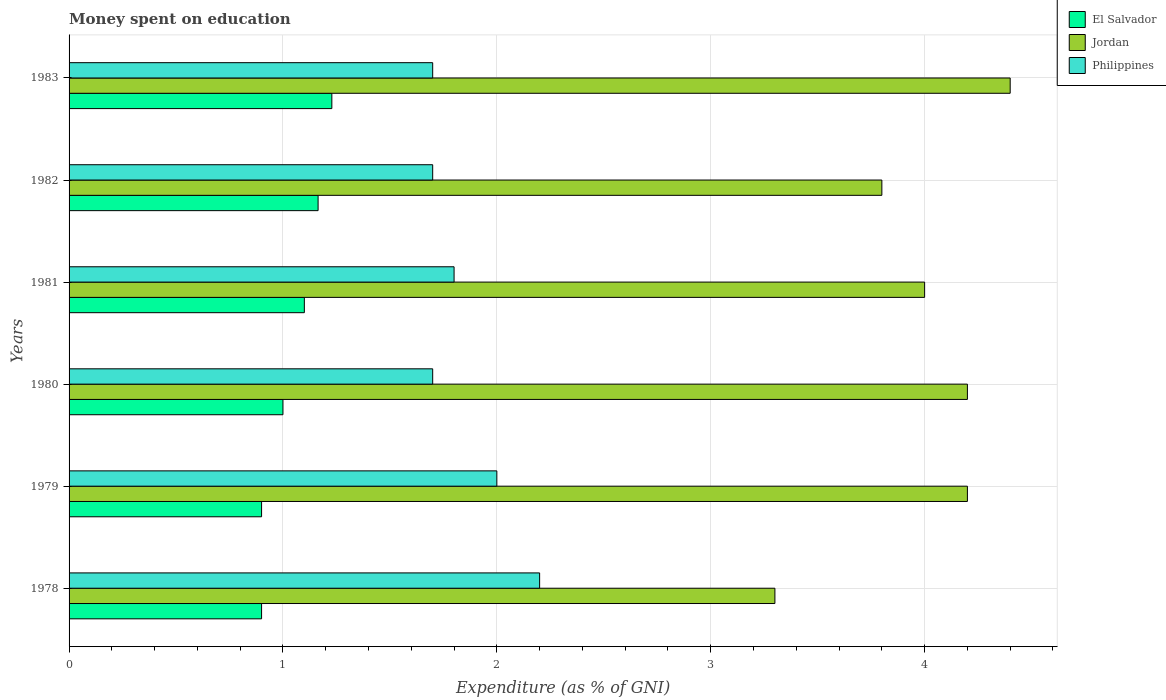How many different coloured bars are there?
Your response must be concise. 3. Are the number of bars per tick equal to the number of legend labels?
Provide a short and direct response. Yes. How many bars are there on the 2nd tick from the bottom?
Provide a short and direct response. 3. What is the label of the 3rd group of bars from the top?
Provide a succinct answer. 1981. In how many cases, is the number of bars for a given year not equal to the number of legend labels?
Provide a short and direct response. 0. What is the amount of money spent on education in Philippines in 1983?
Keep it short and to the point. 1.7. Across all years, what is the minimum amount of money spent on education in El Salvador?
Provide a succinct answer. 0.9. In which year was the amount of money spent on education in El Salvador maximum?
Provide a short and direct response. 1983. In which year was the amount of money spent on education in El Salvador minimum?
Make the answer very short. 1978. What is the total amount of money spent on education in Jordan in the graph?
Your answer should be compact. 23.9. What is the difference between the amount of money spent on education in Jordan in 1981 and that in 1983?
Make the answer very short. -0.4. What is the difference between the amount of money spent on education in Jordan in 1983 and the amount of money spent on education in El Salvador in 1982?
Your answer should be compact. 3.24. What is the average amount of money spent on education in Philippines per year?
Your answer should be compact. 1.85. In the year 1983, what is the difference between the amount of money spent on education in Jordan and amount of money spent on education in Philippines?
Make the answer very short. 2.7. What is the ratio of the amount of money spent on education in Philippines in 1979 to that in 1983?
Offer a very short reply. 1.18. Is the difference between the amount of money spent on education in Jordan in 1978 and 1981 greater than the difference between the amount of money spent on education in Philippines in 1978 and 1981?
Provide a short and direct response. No. What is the difference between the highest and the second highest amount of money spent on education in Philippines?
Provide a short and direct response. 0.2. What is the difference between the highest and the lowest amount of money spent on education in El Salvador?
Ensure brevity in your answer.  0.33. What does the 2nd bar from the top in 1982 represents?
Keep it short and to the point. Jordan. What does the 1st bar from the bottom in 1982 represents?
Offer a very short reply. El Salvador. Is it the case that in every year, the sum of the amount of money spent on education in El Salvador and amount of money spent on education in Philippines is greater than the amount of money spent on education in Jordan?
Provide a short and direct response. No. How many bars are there?
Your answer should be compact. 18. Are all the bars in the graph horizontal?
Your answer should be very brief. Yes. How many years are there in the graph?
Make the answer very short. 6. What is the difference between two consecutive major ticks on the X-axis?
Provide a succinct answer. 1. Does the graph contain grids?
Offer a terse response. Yes. Where does the legend appear in the graph?
Keep it short and to the point. Top right. How are the legend labels stacked?
Your answer should be very brief. Vertical. What is the title of the graph?
Provide a succinct answer. Money spent on education. Does "Andorra" appear as one of the legend labels in the graph?
Your answer should be very brief. No. What is the label or title of the X-axis?
Offer a terse response. Expenditure (as % of GNI). What is the label or title of the Y-axis?
Your response must be concise. Years. What is the Expenditure (as % of GNI) in El Salvador in 1978?
Your answer should be compact. 0.9. What is the Expenditure (as % of GNI) in Jordan in 1978?
Your answer should be compact. 3.3. What is the Expenditure (as % of GNI) of Philippines in 1978?
Your response must be concise. 2.2. What is the Expenditure (as % of GNI) of El Salvador in 1980?
Give a very brief answer. 1. What is the Expenditure (as % of GNI) in Jordan in 1980?
Your answer should be compact. 4.2. What is the Expenditure (as % of GNI) of Philippines in 1980?
Offer a terse response. 1.7. What is the Expenditure (as % of GNI) of El Salvador in 1981?
Your response must be concise. 1.1. What is the Expenditure (as % of GNI) of Philippines in 1981?
Keep it short and to the point. 1.8. What is the Expenditure (as % of GNI) in El Salvador in 1982?
Offer a very short reply. 1.16. What is the Expenditure (as % of GNI) of El Salvador in 1983?
Provide a short and direct response. 1.23. What is the Expenditure (as % of GNI) in Jordan in 1983?
Your answer should be very brief. 4.4. What is the Expenditure (as % of GNI) of Philippines in 1983?
Keep it short and to the point. 1.7. Across all years, what is the maximum Expenditure (as % of GNI) in El Salvador?
Your response must be concise. 1.23. Across all years, what is the maximum Expenditure (as % of GNI) of Jordan?
Keep it short and to the point. 4.4. Across all years, what is the minimum Expenditure (as % of GNI) of El Salvador?
Your response must be concise. 0.9. Across all years, what is the minimum Expenditure (as % of GNI) in Jordan?
Offer a very short reply. 3.3. What is the total Expenditure (as % of GNI) of El Salvador in the graph?
Provide a succinct answer. 6.29. What is the total Expenditure (as % of GNI) of Jordan in the graph?
Keep it short and to the point. 23.9. What is the total Expenditure (as % of GNI) in Philippines in the graph?
Offer a terse response. 11.1. What is the difference between the Expenditure (as % of GNI) of Jordan in 1978 and that in 1979?
Make the answer very short. -0.9. What is the difference between the Expenditure (as % of GNI) in Philippines in 1978 and that in 1979?
Offer a very short reply. 0.2. What is the difference between the Expenditure (as % of GNI) of Philippines in 1978 and that in 1980?
Your response must be concise. 0.5. What is the difference between the Expenditure (as % of GNI) of Philippines in 1978 and that in 1981?
Your answer should be very brief. 0.4. What is the difference between the Expenditure (as % of GNI) in El Salvador in 1978 and that in 1982?
Give a very brief answer. -0.26. What is the difference between the Expenditure (as % of GNI) in Philippines in 1978 and that in 1982?
Give a very brief answer. 0.5. What is the difference between the Expenditure (as % of GNI) of El Salvador in 1978 and that in 1983?
Provide a short and direct response. -0.33. What is the difference between the Expenditure (as % of GNI) in Jordan in 1978 and that in 1983?
Your answer should be compact. -1.1. What is the difference between the Expenditure (as % of GNI) of Jordan in 1979 and that in 1981?
Provide a short and direct response. 0.2. What is the difference between the Expenditure (as % of GNI) in Philippines in 1979 and that in 1981?
Ensure brevity in your answer.  0.2. What is the difference between the Expenditure (as % of GNI) in El Salvador in 1979 and that in 1982?
Provide a succinct answer. -0.26. What is the difference between the Expenditure (as % of GNI) of Jordan in 1979 and that in 1982?
Your answer should be compact. 0.4. What is the difference between the Expenditure (as % of GNI) of Philippines in 1979 and that in 1982?
Offer a terse response. 0.3. What is the difference between the Expenditure (as % of GNI) of El Salvador in 1979 and that in 1983?
Your answer should be very brief. -0.33. What is the difference between the Expenditure (as % of GNI) of Jordan in 1979 and that in 1983?
Keep it short and to the point. -0.2. What is the difference between the Expenditure (as % of GNI) of Philippines in 1979 and that in 1983?
Provide a succinct answer. 0.3. What is the difference between the Expenditure (as % of GNI) of El Salvador in 1980 and that in 1982?
Make the answer very short. -0.16. What is the difference between the Expenditure (as % of GNI) of Philippines in 1980 and that in 1982?
Your answer should be compact. 0. What is the difference between the Expenditure (as % of GNI) in El Salvador in 1980 and that in 1983?
Keep it short and to the point. -0.23. What is the difference between the Expenditure (as % of GNI) in Jordan in 1980 and that in 1983?
Your answer should be very brief. -0.2. What is the difference between the Expenditure (as % of GNI) of Philippines in 1980 and that in 1983?
Provide a short and direct response. 0. What is the difference between the Expenditure (as % of GNI) of El Salvador in 1981 and that in 1982?
Your answer should be compact. -0.06. What is the difference between the Expenditure (as % of GNI) of Jordan in 1981 and that in 1982?
Make the answer very short. 0.2. What is the difference between the Expenditure (as % of GNI) in Philippines in 1981 and that in 1982?
Give a very brief answer. 0.1. What is the difference between the Expenditure (as % of GNI) in El Salvador in 1981 and that in 1983?
Offer a terse response. -0.13. What is the difference between the Expenditure (as % of GNI) of Jordan in 1981 and that in 1983?
Keep it short and to the point. -0.4. What is the difference between the Expenditure (as % of GNI) in El Salvador in 1982 and that in 1983?
Your answer should be very brief. -0.06. What is the difference between the Expenditure (as % of GNI) of Jordan in 1982 and that in 1983?
Your answer should be very brief. -0.6. What is the difference between the Expenditure (as % of GNI) of Philippines in 1982 and that in 1983?
Give a very brief answer. 0. What is the difference between the Expenditure (as % of GNI) in El Salvador in 1978 and the Expenditure (as % of GNI) in Jordan in 1979?
Ensure brevity in your answer.  -3.3. What is the difference between the Expenditure (as % of GNI) of Jordan in 1978 and the Expenditure (as % of GNI) of Philippines in 1979?
Your answer should be very brief. 1.3. What is the difference between the Expenditure (as % of GNI) in Jordan in 1978 and the Expenditure (as % of GNI) in Philippines in 1981?
Your answer should be compact. 1.5. What is the difference between the Expenditure (as % of GNI) of El Salvador in 1978 and the Expenditure (as % of GNI) of Jordan in 1982?
Give a very brief answer. -2.9. What is the difference between the Expenditure (as % of GNI) of El Salvador in 1978 and the Expenditure (as % of GNI) of Philippines in 1982?
Your response must be concise. -0.8. What is the difference between the Expenditure (as % of GNI) in Jordan in 1978 and the Expenditure (as % of GNI) in Philippines in 1982?
Keep it short and to the point. 1.6. What is the difference between the Expenditure (as % of GNI) in El Salvador in 1978 and the Expenditure (as % of GNI) in Jordan in 1983?
Offer a very short reply. -3.5. What is the difference between the Expenditure (as % of GNI) in El Salvador in 1978 and the Expenditure (as % of GNI) in Philippines in 1983?
Offer a very short reply. -0.8. What is the difference between the Expenditure (as % of GNI) of Jordan in 1978 and the Expenditure (as % of GNI) of Philippines in 1983?
Make the answer very short. 1.6. What is the difference between the Expenditure (as % of GNI) of El Salvador in 1979 and the Expenditure (as % of GNI) of Philippines in 1980?
Provide a succinct answer. -0.8. What is the difference between the Expenditure (as % of GNI) of Jordan in 1979 and the Expenditure (as % of GNI) of Philippines in 1980?
Ensure brevity in your answer.  2.5. What is the difference between the Expenditure (as % of GNI) of El Salvador in 1979 and the Expenditure (as % of GNI) of Jordan in 1982?
Provide a succinct answer. -2.9. What is the difference between the Expenditure (as % of GNI) in El Salvador in 1979 and the Expenditure (as % of GNI) in Philippines in 1982?
Provide a short and direct response. -0.8. What is the difference between the Expenditure (as % of GNI) of Jordan in 1979 and the Expenditure (as % of GNI) of Philippines in 1982?
Your answer should be compact. 2.5. What is the difference between the Expenditure (as % of GNI) of El Salvador in 1979 and the Expenditure (as % of GNI) of Jordan in 1983?
Your answer should be compact. -3.5. What is the difference between the Expenditure (as % of GNI) of El Salvador in 1980 and the Expenditure (as % of GNI) of Philippines in 1981?
Offer a terse response. -0.8. What is the difference between the Expenditure (as % of GNI) of Jordan in 1980 and the Expenditure (as % of GNI) of Philippines in 1981?
Give a very brief answer. 2.4. What is the difference between the Expenditure (as % of GNI) in Jordan in 1980 and the Expenditure (as % of GNI) in Philippines in 1982?
Your response must be concise. 2.5. What is the difference between the Expenditure (as % of GNI) in El Salvador in 1980 and the Expenditure (as % of GNI) in Jordan in 1983?
Provide a succinct answer. -3.4. What is the difference between the Expenditure (as % of GNI) of El Salvador in 1980 and the Expenditure (as % of GNI) of Philippines in 1983?
Offer a very short reply. -0.7. What is the difference between the Expenditure (as % of GNI) in El Salvador in 1981 and the Expenditure (as % of GNI) in Jordan in 1982?
Make the answer very short. -2.7. What is the difference between the Expenditure (as % of GNI) in Jordan in 1981 and the Expenditure (as % of GNI) in Philippines in 1982?
Provide a short and direct response. 2.3. What is the difference between the Expenditure (as % of GNI) in El Salvador in 1981 and the Expenditure (as % of GNI) in Jordan in 1983?
Offer a terse response. -3.3. What is the difference between the Expenditure (as % of GNI) of El Salvador in 1982 and the Expenditure (as % of GNI) of Jordan in 1983?
Offer a terse response. -3.24. What is the difference between the Expenditure (as % of GNI) in El Salvador in 1982 and the Expenditure (as % of GNI) in Philippines in 1983?
Make the answer very short. -0.54. What is the average Expenditure (as % of GNI) in El Salvador per year?
Make the answer very short. 1.05. What is the average Expenditure (as % of GNI) of Jordan per year?
Provide a short and direct response. 3.98. What is the average Expenditure (as % of GNI) of Philippines per year?
Your answer should be very brief. 1.85. In the year 1978, what is the difference between the Expenditure (as % of GNI) of El Salvador and Expenditure (as % of GNI) of Jordan?
Make the answer very short. -2.4. In the year 1978, what is the difference between the Expenditure (as % of GNI) of El Salvador and Expenditure (as % of GNI) of Philippines?
Give a very brief answer. -1.3. In the year 1979, what is the difference between the Expenditure (as % of GNI) in El Salvador and Expenditure (as % of GNI) in Philippines?
Provide a succinct answer. -1.1. In the year 1979, what is the difference between the Expenditure (as % of GNI) of Jordan and Expenditure (as % of GNI) of Philippines?
Your answer should be compact. 2.2. In the year 1980, what is the difference between the Expenditure (as % of GNI) of Jordan and Expenditure (as % of GNI) of Philippines?
Your answer should be compact. 2.5. In the year 1981, what is the difference between the Expenditure (as % of GNI) of El Salvador and Expenditure (as % of GNI) of Philippines?
Offer a terse response. -0.7. In the year 1981, what is the difference between the Expenditure (as % of GNI) in Jordan and Expenditure (as % of GNI) in Philippines?
Your answer should be very brief. 2.2. In the year 1982, what is the difference between the Expenditure (as % of GNI) in El Salvador and Expenditure (as % of GNI) in Jordan?
Offer a terse response. -2.64. In the year 1982, what is the difference between the Expenditure (as % of GNI) in El Salvador and Expenditure (as % of GNI) in Philippines?
Make the answer very short. -0.54. In the year 1983, what is the difference between the Expenditure (as % of GNI) of El Salvador and Expenditure (as % of GNI) of Jordan?
Provide a succinct answer. -3.17. In the year 1983, what is the difference between the Expenditure (as % of GNI) in El Salvador and Expenditure (as % of GNI) in Philippines?
Your response must be concise. -0.47. In the year 1983, what is the difference between the Expenditure (as % of GNI) of Jordan and Expenditure (as % of GNI) of Philippines?
Offer a very short reply. 2.7. What is the ratio of the Expenditure (as % of GNI) of El Salvador in 1978 to that in 1979?
Your answer should be very brief. 1. What is the ratio of the Expenditure (as % of GNI) of Jordan in 1978 to that in 1979?
Your answer should be compact. 0.79. What is the ratio of the Expenditure (as % of GNI) of Philippines in 1978 to that in 1979?
Provide a short and direct response. 1.1. What is the ratio of the Expenditure (as % of GNI) of El Salvador in 1978 to that in 1980?
Offer a terse response. 0.9. What is the ratio of the Expenditure (as % of GNI) in Jordan in 1978 to that in 1980?
Give a very brief answer. 0.79. What is the ratio of the Expenditure (as % of GNI) in Philippines in 1978 to that in 1980?
Offer a terse response. 1.29. What is the ratio of the Expenditure (as % of GNI) of El Salvador in 1978 to that in 1981?
Offer a terse response. 0.82. What is the ratio of the Expenditure (as % of GNI) in Jordan in 1978 to that in 1981?
Your response must be concise. 0.82. What is the ratio of the Expenditure (as % of GNI) of Philippines in 1978 to that in 1981?
Ensure brevity in your answer.  1.22. What is the ratio of the Expenditure (as % of GNI) of El Salvador in 1978 to that in 1982?
Keep it short and to the point. 0.77. What is the ratio of the Expenditure (as % of GNI) in Jordan in 1978 to that in 1982?
Offer a very short reply. 0.87. What is the ratio of the Expenditure (as % of GNI) of Philippines in 1978 to that in 1982?
Your answer should be very brief. 1.29. What is the ratio of the Expenditure (as % of GNI) of El Salvador in 1978 to that in 1983?
Give a very brief answer. 0.73. What is the ratio of the Expenditure (as % of GNI) in Jordan in 1978 to that in 1983?
Your answer should be compact. 0.75. What is the ratio of the Expenditure (as % of GNI) in Philippines in 1978 to that in 1983?
Offer a very short reply. 1.29. What is the ratio of the Expenditure (as % of GNI) of Philippines in 1979 to that in 1980?
Your answer should be compact. 1.18. What is the ratio of the Expenditure (as % of GNI) of El Salvador in 1979 to that in 1981?
Give a very brief answer. 0.82. What is the ratio of the Expenditure (as % of GNI) in Philippines in 1979 to that in 1981?
Offer a terse response. 1.11. What is the ratio of the Expenditure (as % of GNI) in El Salvador in 1979 to that in 1982?
Your response must be concise. 0.77. What is the ratio of the Expenditure (as % of GNI) in Jordan in 1979 to that in 1982?
Make the answer very short. 1.11. What is the ratio of the Expenditure (as % of GNI) of Philippines in 1979 to that in 1982?
Your answer should be compact. 1.18. What is the ratio of the Expenditure (as % of GNI) in El Salvador in 1979 to that in 1983?
Your answer should be very brief. 0.73. What is the ratio of the Expenditure (as % of GNI) of Jordan in 1979 to that in 1983?
Provide a short and direct response. 0.95. What is the ratio of the Expenditure (as % of GNI) of Philippines in 1979 to that in 1983?
Keep it short and to the point. 1.18. What is the ratio of the Expenditure (as % of GNI) of El Salvador in 1980 to that in 1981?
Your answer should be compact. 0.91. What is the ratio of the Expenditure (as % of GNI) in Jordan in 1980 to that in 1981?
Offer a terse response. 1.05. What is the ratio of the Expenditure (as % of GNI) in El Salvador in 1980 to that in 1982?
Give a very brief answer. 0.86. What is the ratio of the Expenditure (as % of GNI) in Jordan in 1980 to that in 1982?
Ensure brevity in your answer.  1.11. What is the ratio of the Expenditure (as % of GNI) of El Salvador in 1980 to that in 1983?
Give a very brief answer. 0.81. What is the ratio of the Expenditure (as % of GNI) of Jordan in 1980 to that in 1983?
Your answer should be compact. 0.95. What is the ratio of the Expenditure (as % of GNI) in Philippines in 1980 to that in 1983?
Make the answer very short. 1. What is the ratio of the Expenditure (as % of GNI) in El Salvador in 1981 to that in 1982?
Ensure brevity in your answer.  0.94. What is the ratio of the Expenditure (as % of GNI) of Jordan in 1981 to that in 1982?
Your answer should be compact. 1.05. What is the ratio of the Expenditure (as % of GNI) of Philippines in 1981 to that in 1982?
Offer a very short reply. 1.06. What is the ratio of the Expenditure (as % of GNI) in El Salvador in 1981 to that in 1983?
Provide a succinct answer. 0.9. What is the ratio of the Expenditure (as % of GNI) in Jordan in 1981 to that in 1983?
Give a very brief answer. 0.91. What is the ratio of the Expenditure (as % of GNI) of Philippines in 1981 to that in 1983?
Offer a terse response. 1.06. What is the ratio of the Expenditure (as % of GNI) in El Salvador in 1982 to that in 1983?
Your answer should be compact. 0.95. What is the ratio of the Expenditure (as % of GNI) in Jordan in 1982 to that in 1983?
Make the answer very short. 0.86. What is the difference between the highest and the second highest Expenditure (as % of GNI) of El Salvador?
Provide a short and direct response. 0.06. What is the difference between the highest and the lowest Expenditure (as % of GNI) of El Salvador?
Offer a very short reply. 0.33. What is the difference between the highest and the lowest Expenditure (as % of GNI) of Jordan?
Keep it short and to the point. 1.1. What is the difference between the highest and the lowest Expenditure (as % of GNI) in Philippines?
Your answer should be very brief. 0.5. 